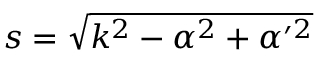Convert formula to latex. <formula><loc_0><loc_0><loc_500><loc_500>s = \sqrt { k ^ { 2 } - \alpha ^ { 2 } + \alpha ^ { \prime 2 } }</formula> 